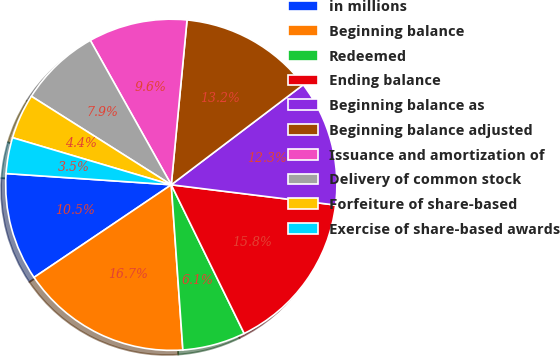Convert chart. <chart><loc_0><loc_0><loc_500><loc_500><pie_chart><fcel>in millions<fcel>Beginning balance<fcel>Redeemed<fcel>Ending balance<fcel>Beginning balance as<fcel>Beginning balance adjusted<fcel>Issuance and amortization of<fcel>Delivery of common stock<fcel>Forfeiture of share-based<fcel>Exercise of share-based awards<nl><fcel>10.53%<fcel>16.67%<fcel>6.14%<fcel>15.79%<fcel>12.28%<fcel>13.16%<fcel>9.65%<fcel>7.89%<fcel>4.39%<fcel>3.51%<nl></chart> 